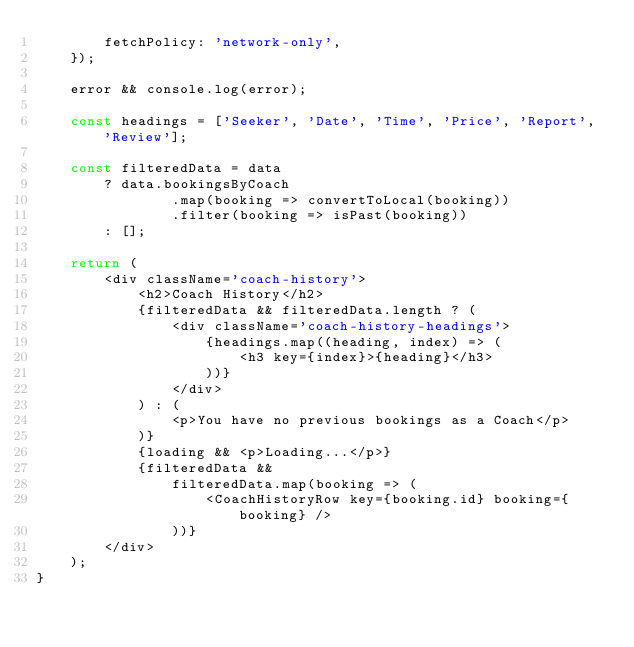Convert code to text. <code><loc_0><loc_0><loc_500><loc_500><_JavaScript_>		fetchPolicy: 'network-only',
	});

	error && console.log(error);

	const headings = ['Seeker', 'Date', 'Time', 'Price', 'Report', 'Review'];

	const filteredData = data
		? data.bookingsByCoach
				.map(booking => convertToLocal(booking))
				.filter(booking => isPast(booking))
		: [];

	return (
		<div className='coach-history'>
			<h2>Coach History</h2>
			{filteredData && filteredData.length ? (
				<div className='coach-history-headings'>
					{headings.map((heading, index) => (
						<h3 key={index}>{heading}</h3>
					))}
				</div>
			) : (
				<p>You have no previous bookings as a Coach</p>
			)}
			{loading && <p>Loading...</p>}
			{filteredData &&
				filteredData.map(booking => (
					<CoachHistoryRow key={booking.id} booking={booking} />
				))}
		</div>
	);
}
</code> 